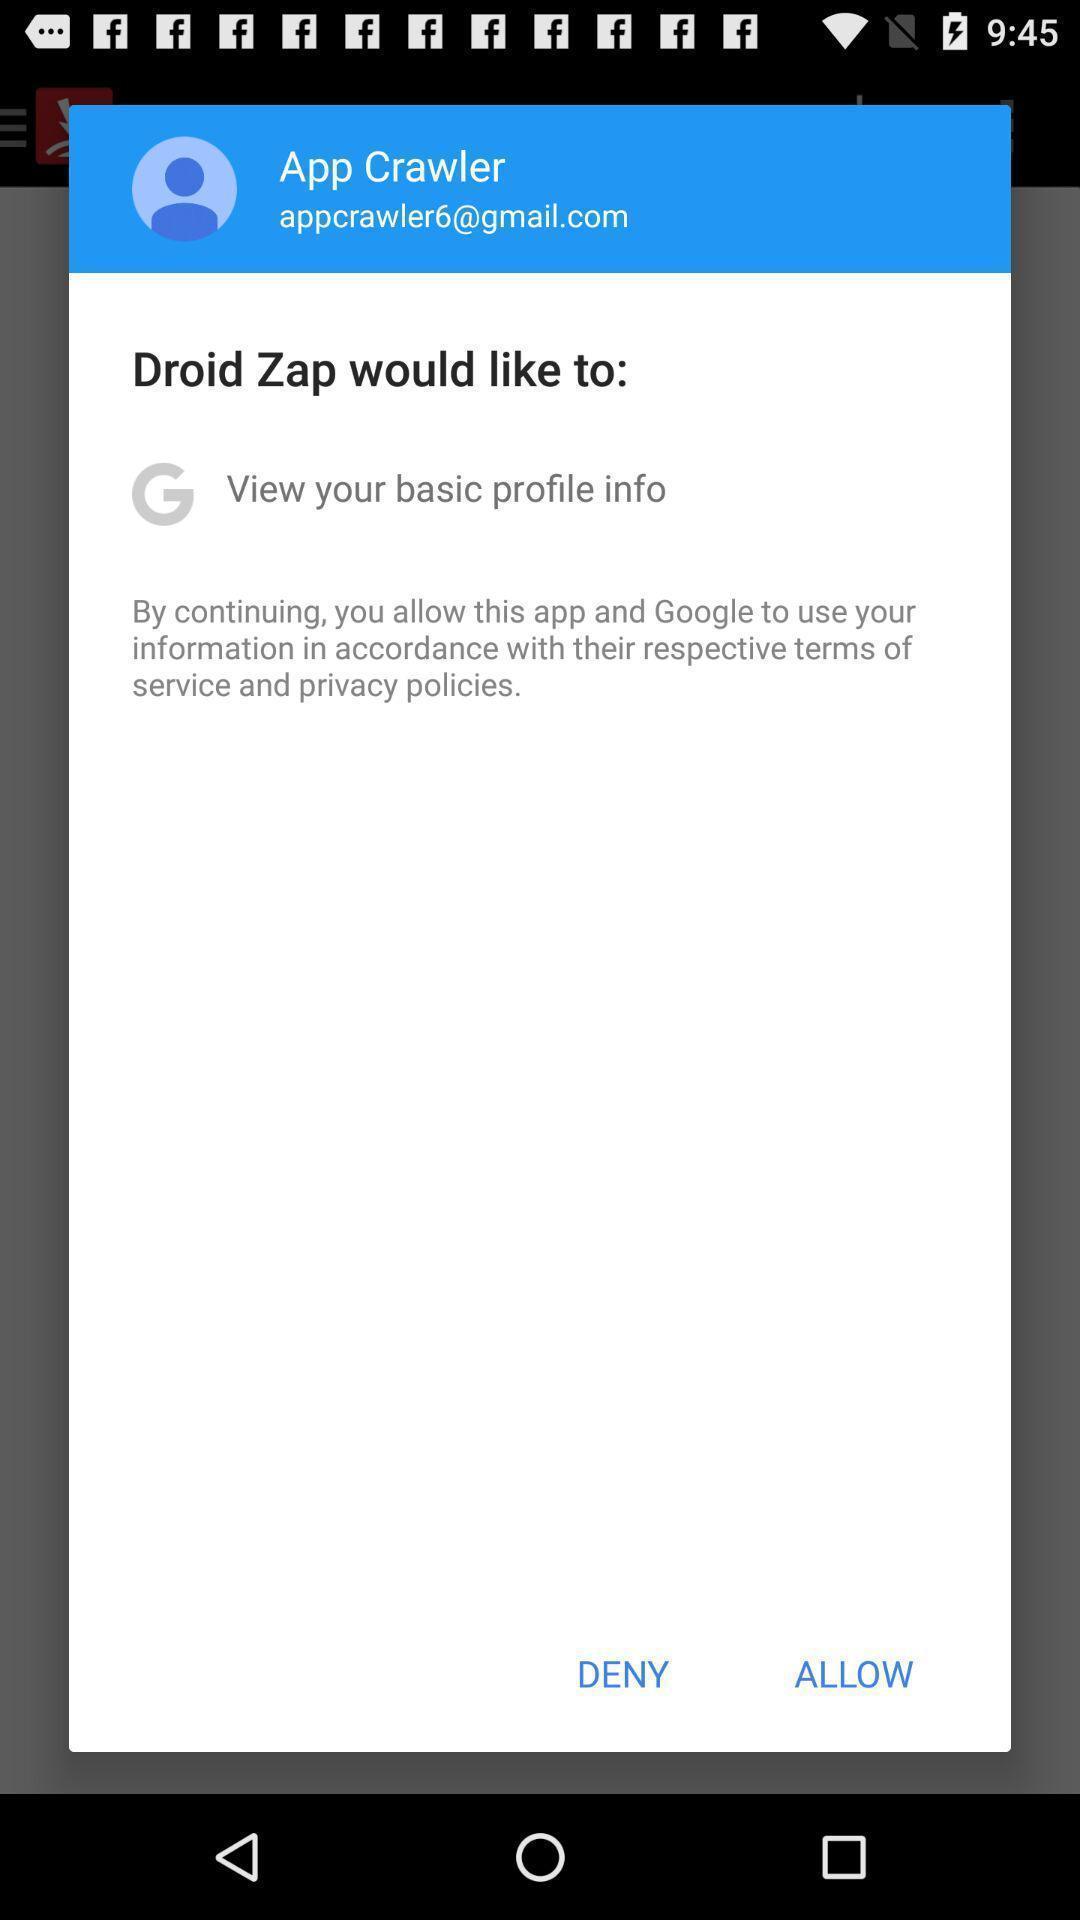Tell me what you see in this picture. Pop-up showing to allow to use information. 